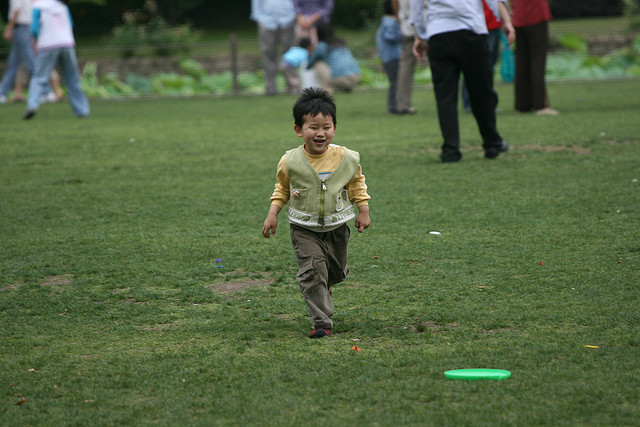Does it look like a special event is taking place? There's no clear indication of a special event in the immediate vicinity of the child; however, the presence of multiple people in the background could suggest a community gathering or simply a busy day at the park. 